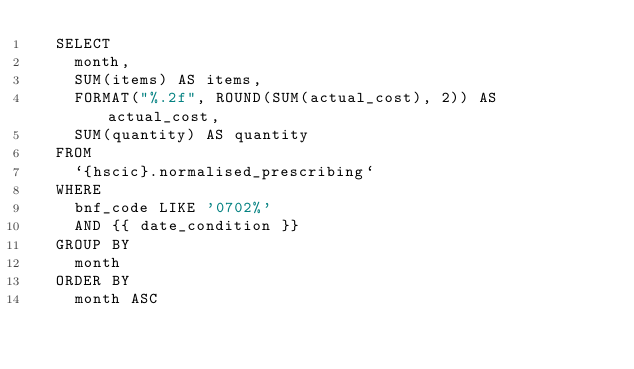<code> <loc_0><loc_0><loc_500><loc_500><_SQL_>  SELECT
    month,
    SUM(items) AS items,
    FORMAT("%.2f", ROUND(SUM(actual_cost), 2)) AS actual_cost,
    SUM(quantity) AS quantity
  FROM
    `{hscic}.normalised_prescribing`
  WHERE
    bnf_code LIKE '0702%'
    AND {{ date_condition }}
  GROUP BY
    month
  ORDER BY
    month ASC
</code> 